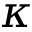<formula> <loc_0><loc_0><loc_500><loc_500>\kappa</formula> 